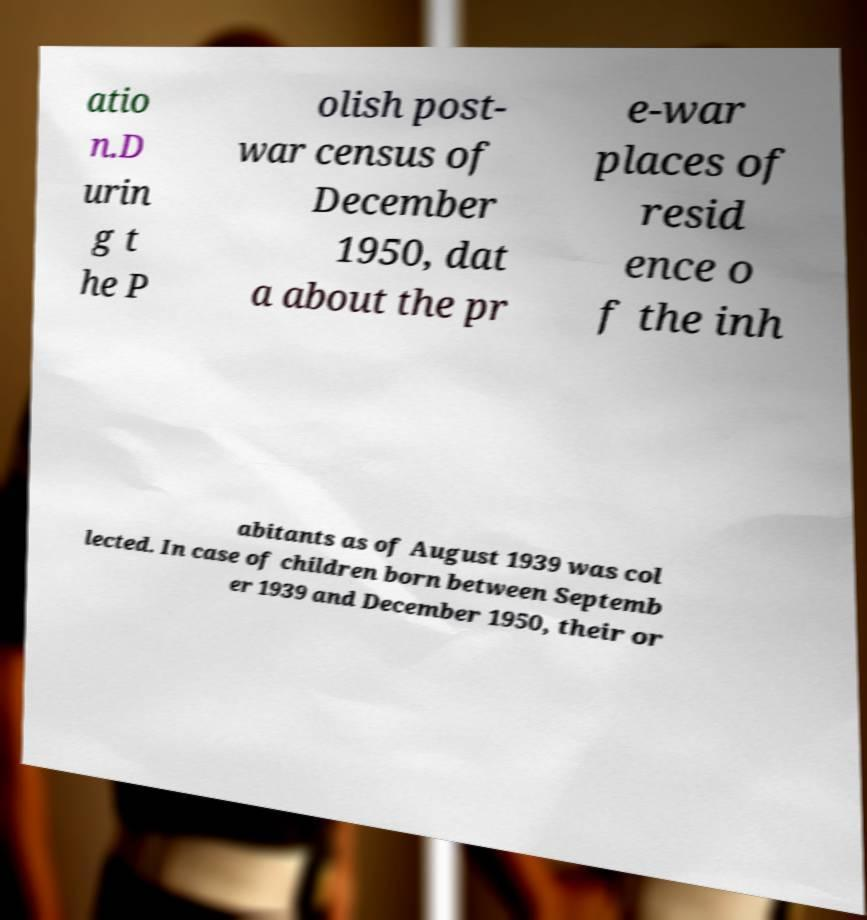Please read and relay the text visible in this image. What does it say? atio n.D urin g t he P olish post- war census of December 1950, dat a about the pr e-war places of resid ence o f the inh abitants as of August 1939 was col lected. In case of children born between Septemb er 1939 and December 1950, their or 